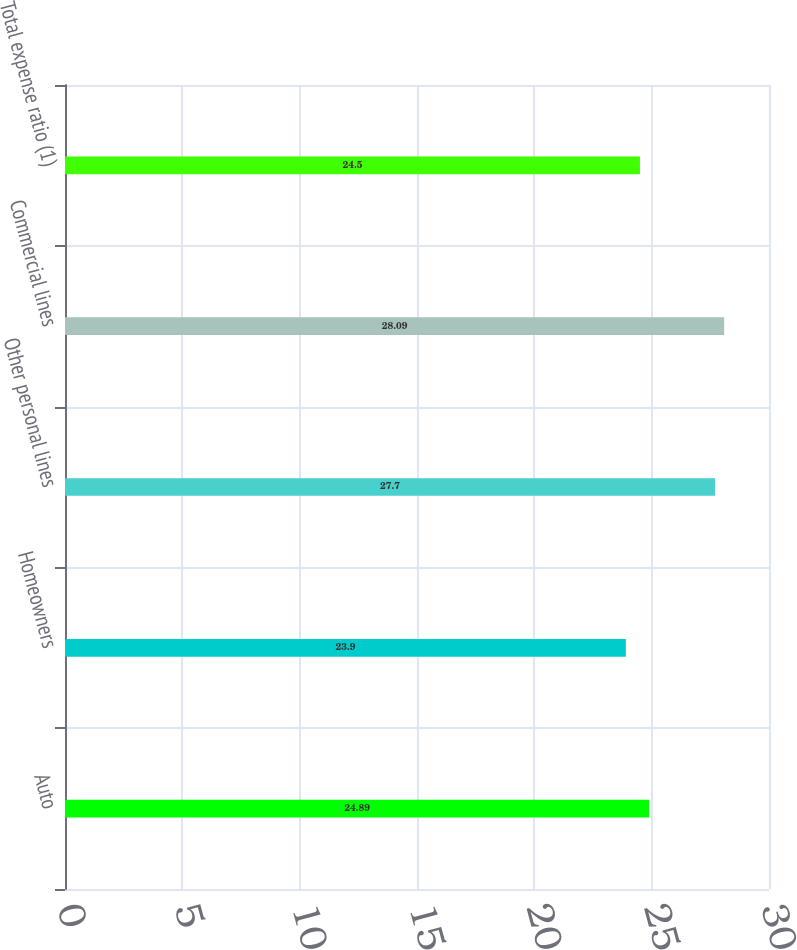Convert chart to OTSL. <chart><loc_0><loc_0><loc_500><loc_500><bar_chart><fcel>Auto<fcel>Homeowners<fcel>Other personal lines<fcel>Commercial lines<fcel>Total expense ratio (1)<nl><fcel>24.89<fcel>23.9<fcel>27.7<fcel>28.09<fcel>24.5<nl></chart> 